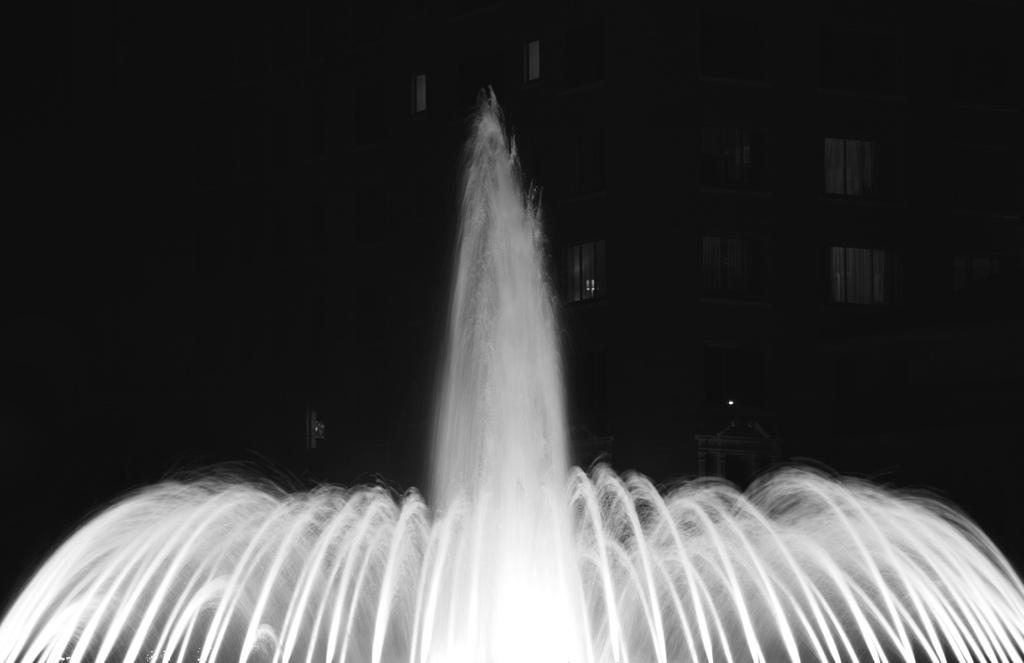What can be seen at the bottom of the picture? There are fountains at the bottom of the picture. What is the color of the background in the image? The background of the image is black in color. Can you describe the lighting conditions in the image? The image might have been taken in a dark environment, as suggested by the black background. Is there a record player visible in the image? There is no mention of a record player or any music-related objects in the provided facts, so it cannot be determined if one is present in the image. 